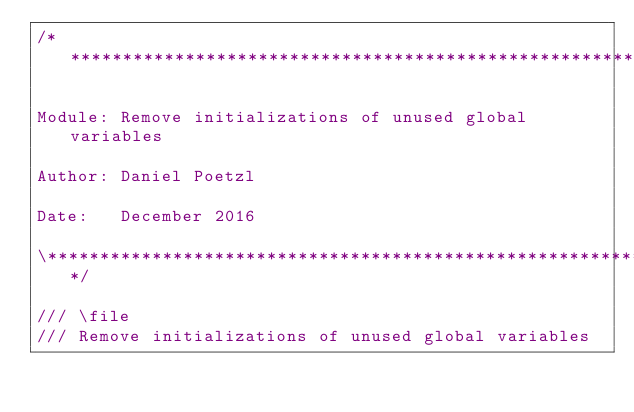<code> <loc_0><loc_0><loc_500><loc_500><_C++_>/*******************************************************************\

Module: Remove initializations of unused global variables

Author: Daniel Poetzl

Date:   December 2016

\*******************************************************************/

/// \file
/// Remove initializations of unused global variables
</code> 